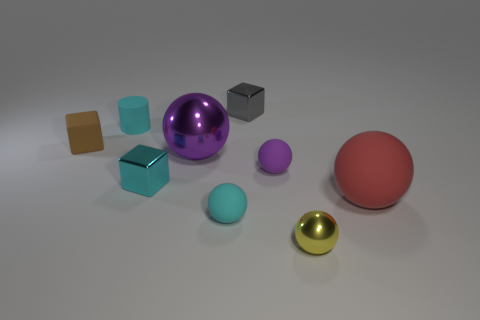Add 1 small cylinders. How many objects exist? 10 Subtract all spheres. How many objects are left? 4 Subtract all large purple metallic things. Subtract all red things. How many objects are left? 7 Add 4 red things. How many red things are left? 5 Add 3 blue rubber cubes. How many blue rubber cubes exist? 3 Subtract 0 gray balls. How many objects are left? 9 